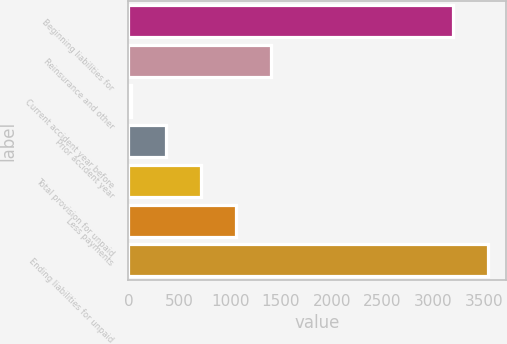Convert chart to OTSL. <chart><loc_0><loc_0><loc_500><loc_500><bar_chart><fcel>Beginning liabilities for<fcel>Reinsurance and other<fcel>Current accident year before<fcel>Prior accident year<fcel>Total provision for unpaid<fcel>Less payments<fcel>Ending liabilities for unpaid<nl><fcel>3195.2<fcel>1401.8<fcel>25<fcel>369.2<fcel>713.4<fcel>1057.6<fcel>3539.4<nl></chart> 